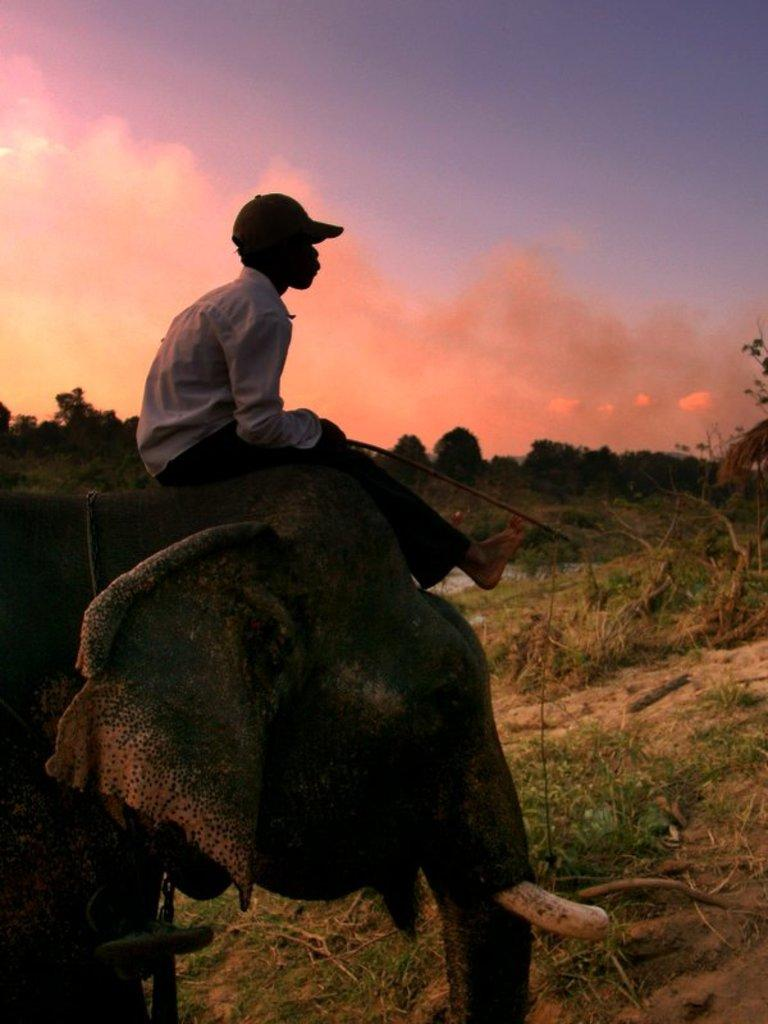What is the man doing in the image? The man is seated on an Elephant head in the image. What can be seen in the background of the image? There are trees visible in the image. How would you describe the sky in the image? The sky is cloudy in the image. What type of advertisement is being displayed on the man's toe in the image? There is no advertisement or toe present in the image. 